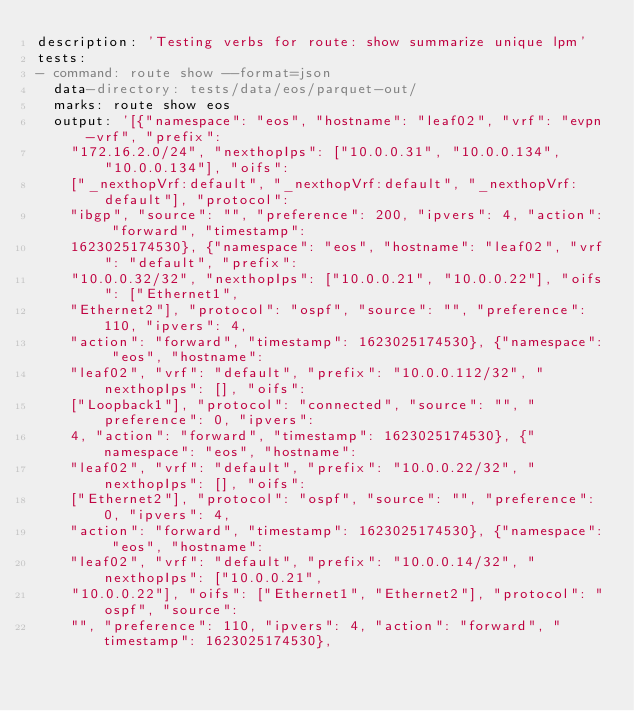Convert code to text. <code><loc_0><loc_0><loc_500><loc_500><_YAML_>description: 'Testing verbs for route: show summarize unique lpm'
tests:
- command: route show --format=json
  data-directory: tests/data/eos/parquet-out/
  marks: route show eos
  output: '[{"namespace": "eos", "hostname": "leaf02", "vrf": "evpn-vrf", "prefix":
    "172.16.2.0/24", "nexthopIps": ["10.0.0.31", "10.0.0.134", "10.0.0.134"], "oifs":
    ["_nexthopVrf:default", "_nexthopVrf:default", "_nexthopVrf:default"], "protocol":
    "ibgp", "source": "", "preference": 200, "ipvers": 4, "action": "forward", "timestamp":
    1623025174530}, {"namespace": "eos", "hostname": "leaf02", "vrf": "default", "prefix":
    "10.0.0.32/32", "nexthopIps": ["10.0.0.21", "10.0.0.22"], "oifs": ["Ethernet1",
    "Ethernet2"], "protocol": "ospf", "source": "", "preference": 110, "ipvers": 4,
    "action": "forward", "timestamp": 1623025174530}, {"namespace": "eos", "hostname":
    "leaf02", "vrf": "default", "prefix": "10.0.0.112/32", "nexthopIps": [], "oifs":
    ["Loopback1"], "protocol": "connected", "source": "", "preference": 0, "ipvers":
    4, "action": "forward", "timestamp": 1623025174530}, {"namespace": "eos", "hostname":
    "leaf02", "vrf": "default", "prefix": "10.0.0.22/32", "nexthopIps": [], "oifs":
    ["Ethernet2"], "protocol": "ospf", "source": "", "preference": 0, "ipvers": 4,
    "action": "forward", "timestamp": 1623025174530}, {"namespace": "eos", "hostname":
    "leaf02", "vrf": "default", "prefix": "10.0.0.14/32", "nexthopIps": ["10.0.0.21",
    "10.0.0.22"], "oifs": ["Ethernet1", "Ethernet2"], "protocol": "ospf", "source":
    "", "preference": 110, "ipvers": 4, "action": "forward", "timestamp": 1623025174530},</code> 